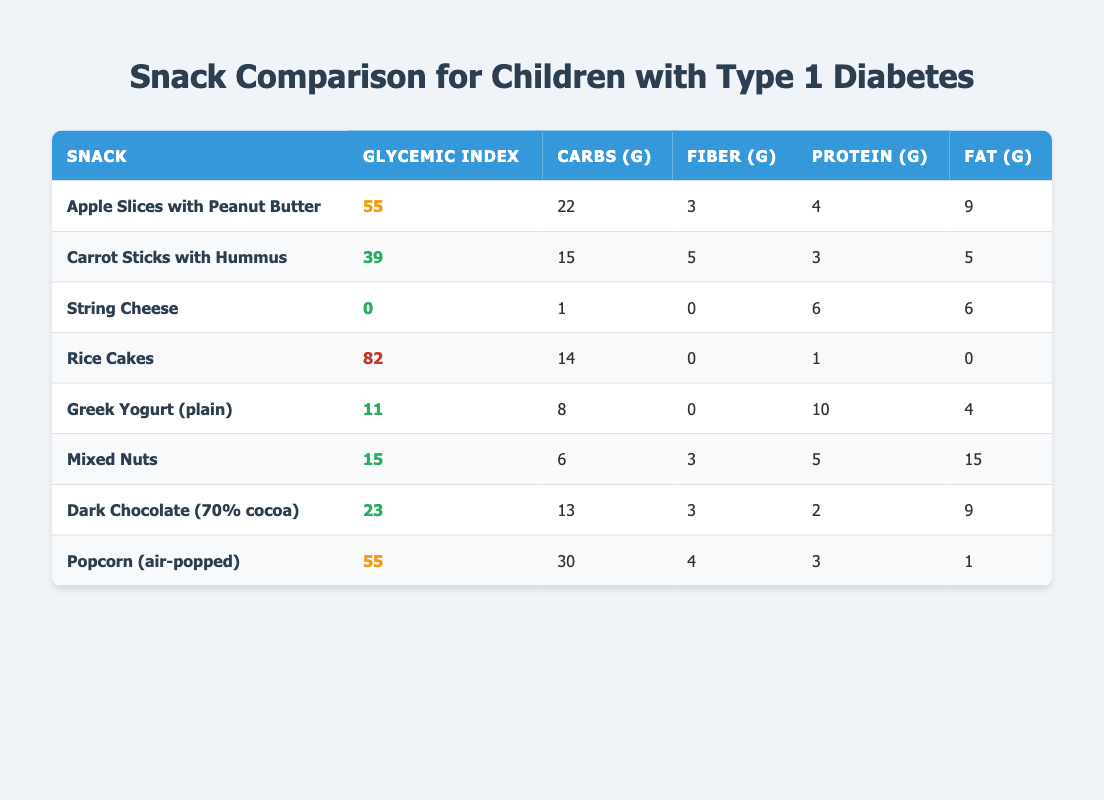What is the glycemic index of Greek Yogurt (plain)? The glycemic index is provided in the table under the "Glycemic Index" column for each snack. For Greek Yogurt (plain), the glycemic index is listed as 11.
Answer: 11 Which snack has the highest glycemic index? By comparing the glycemic index values in the table, Rice Cakes have the highest glycemic index at 82.
Answer: Rice Cakes What is the average carbohydrates per serving among the snacks? To find the average carbohydrates, sum the carbohydrates per serving for all snacks (22 + 15 + 1 + 14 + 8 + 6 + 13 + 30) = 109. There are 8 snacks, so the average is 109/8 = 13.625.
Answer: 13.625 Is String Cheese considered a low glycemic index snack? The glycemic index of String Cheese is 0, which is below the threshold of 55 for low glycemic index. Therefore, it is indeed considered a low glycemic index snack.
Answer: Yes What is the difference in protein content between Mixed Nuts and Greek Yogurt (plain)? The protein content of Mixed Nuts is 5 grams and for Greek Yogurt (plain) is 10 grams. The difference is calculated as 10 - 5 = 5.
Answer: 5 Which snacks contain more than 20 grams of carbohydrates per serving? The table indicates that Apple Slices with Peanut Butter (22g) and Popcorn (air-popped) (30g) both have more than 20 grams of carbohydrates per serving.
Answer: Apple Slices with Peanut Butter and Popcorn (air-popped) How many snacks have a glycemic index under 25? Upon reviewing the glycemic index values in the table, the snacks with indices under 25 are String Cheese (0), Greek Yogurt (plain) (11), Mixed Nuts (15), and Dark Chocolate (23). This totals 4 snacks.
Answer: 4 What is the total fat content for all snacks combined? To find the total fat content, sum the fat per serving for all snacks (9 + 5 + 6 + 0 + 4 + 15 + 9 + 1) = 49 grams total fat.
Answer: 49 Which snack has the least amount of carbohydrates per serving? The table shows that String Cheese has the least amount of carbohydrates at 1 gram per serving.
Answer: String Cheese 